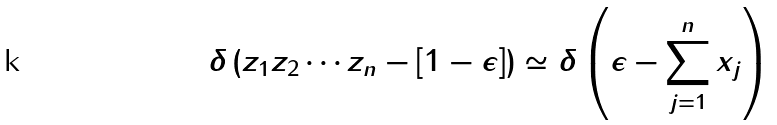Convert formula to latex. <formula><loc_0><loc_0><loc_500><loc_500>\delta \left ( z _ { 1 } z _ { 2 } \cdots z _ { n } - [ 1 - \epsilon ] \right ) \simeq \delta \left ( \epsilon - \sum _ { j = 1 } ^ { n } x _ { j } \right )</formula> 